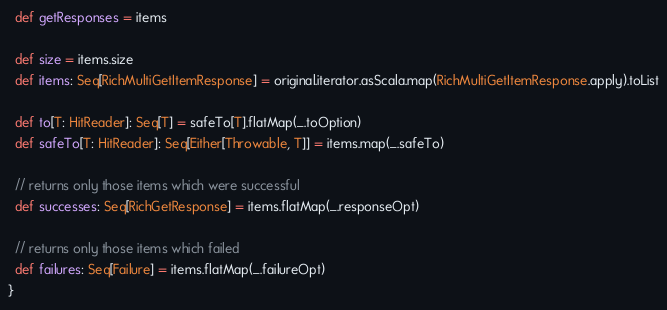Convert code to text. <code><loc_0><loc_0><loc_500><loc_500><_Scala_>  def getResponses = items

  def size = items.size
  def items: Seq[RichMultiGetItemResponse] = original.iterator.asScala.map(RichMultiGetItemResponse.apply).toList

  def to[T: HitReader]: Seq[T] = safeTo[T].flatMap(_.toOption)
  def safeTo[T: HitReader]: Seq[Either[Throwable, T]] = items.map(_.safeTo)

  // returns only those items which were successful
  def successes: Seq[RichGetResponse] = items.flatMap(_.responseOpt)

  // returns only those items which failed
  def failures: Seq[Failure] = items.flatMap(_.failureOpt)
}
</code> 